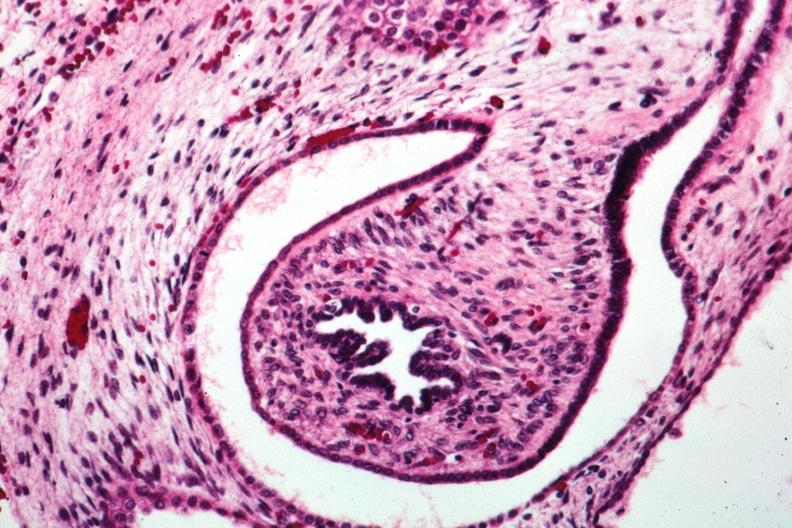s polycystic disease infant present?
Answer the question using a single word or phrase. Yes 